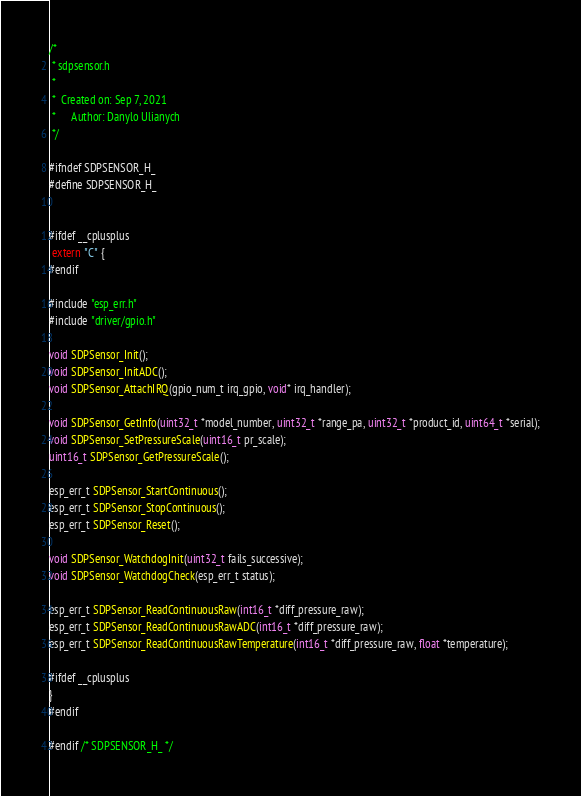Convert code to text. <code><loc_0><loc_0><loc_500><loc_500><_C_>/*
 * sdpsensor.h
 *
 *  Created on: Sep 7, 2021
 *      Author: Danylo Ulianych
 */

#ifndef SDPSENSOR_H_
#define SDPSENSOR_H_


#ifdef __cplusplus
 extern "C" {
#endif

#include "esp_err.h"
#include "driver/gpio.h"

void SDPSensor_Init();
void SDPSensor_InitADC();
void SDPSensor_AttachIRQ(gpio_num_t irq_gpio, void* irq_handler);

void SDPSensor_GetInfo(uint32_t *model_number, uint32_t *range_pa, uint32_t *product_id, uint64_t *serial);
void SDPSensor_SetPressureScale(uint16_t pr_scale);
uint16_t SDPSensor_GetPressureScale();

esp_err_t SDPSensor_StartContinuous();
esp_err_t SDPSensor_StopContinuous();
esp_err_t SDPSensor_Reset();

void SDPSensor_WatchdogInit(uint32_t fails_successive);
void SDPSensor_WatchdogCheck(esp_err_t status);

esp_err_t SDPSensor_ReadContinuousRaw(int16_t *diff_pressure_raw);
esp_err_t SDPSensor_ReadContinuousRawADC(int16_t *diff_pressure_raw);
esp_err_t SDPSensor_ReadContinuousRawTemperature(int16_t *diff_pressure_raw, float *temperature);

#ifdef __cplusplus
}
#endif

#endif /* SDPSENSOR_H_ */
</code> 